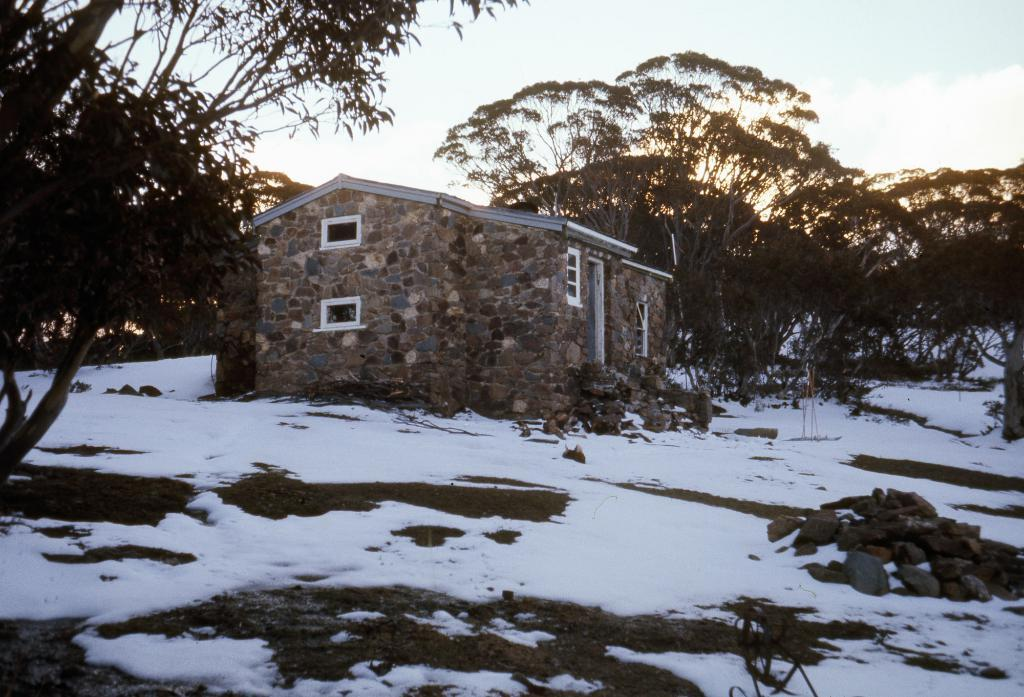What type of structure is present in the image? There is a building in the image. What other natural elements can be seen in the image? There are trees and rocks in the image. How is the ground depicted in the image? The ground is covered with snow in the image. What is visible at the top of the image? The sky is visible at the top of the image. Can you see any clover growing in the snow in the image? There is no clover visible in the image; the focus is on the building, trees, rocks, and snow-covered ground. 